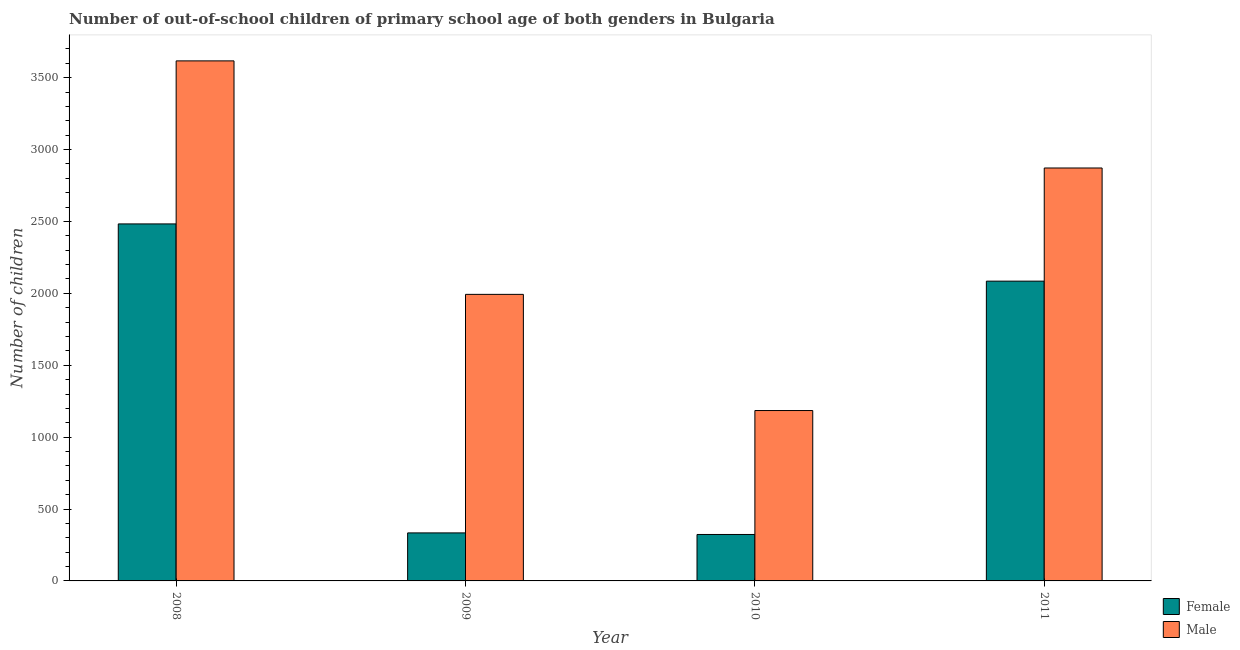How many groups of bars are there?
Make the answer very short. 4. How many bars are there on the 1st tick from the right?
Keep it short and to the point. 2. In how many cases, is the number of bars for a given year not equal to the number of legend labels?
Make the answer very short. 0. What is the number of female out-of-school students in 2010?
Provide a succinct answer. 323. Across all years, what is the maximum number of female out-of-school students?
Provide a short and direct response. 2483. Across all years, what is the minimum number of male out-of-school students?
Keep it short and to the point. 1185. In which year was the number of male out-of-school students maximum?
Keep it short and to the point. 2008. What is the total number of female out-of-school students in the graph?
Give a very brief answer. 5225. What is the difference between the number of male out-of-school students in 2009 and that in 2011?
Offer a terse response. -879. What is the difference between the number of male out-of-school students in 2011 and the number of female out-of-school students in 2008?
Your response must be concise. -745. What is the average number of male out-of-school students per year?
Your answer should be compact. 2416.75. In how many years, is the number of male out-of-school students greater than 300?
Your response must be concise. 4. What is the ratio of the number of female out-of-school students in 2008 to that in 2009?
Ensure brevity in your answer.  7.43. What is the difference between the highest and the second highest number of female out-of-school students?
Ensure brevity in your answer.  398. What is the difference between the highest and the lowest number of male out-of-school students?
Ensure brevity in your answer.  2432. Is the sum of the number of male out-of-school students in 2008 and 2009 greater than the maximum number of female out-of-school students across all years?
Your answer should be compact. Yes. How many bars are there?
Provide a short and direct response. 8. Does the graph contain any zero values?
Your answer should be compact. No. How many legend labels are there?
Offer a very short reply. 2. How are the legend labels stacked?
Offer a very short reply. Vertical. What is the title of the graph?
Make the answer very short. Number of out-of-school children of primary school age of both genders in Bulgaria. What is the label or title of the Y-axis?
Your answer should be very brief. Number of children. What is the Number of children in Female in 2008?
Your answer should be compact. 2483. What is the Number of children in Male in 2008?
Your response must be concise. 3617. What is the Number of children of Female in 2009?
Your response must be concise. 334. What is the Number of children of Male in 2009?
Offer a terse response. 1993. What is the Number of children in Female in 2010?
Provide a succinct answer. 323. What is the Number of children in Male in 2010?
Offer a terse response. 1185. What is the Number of children in Female in 2011?
Offer a terse response. 2085. What is the Number of children in Male in 2011?
Provide a short and direct response. 2872. Across all years, what is the maximum Number of children of Female?
Your response must be concise. 2483. Across all years, what is the maximum Number of children of Male?
Provide a succinct answer. 3617. Across all years, what is the minimum Number of children of Female?
Provide a succinct answer. 323. Across all years, what is the minimum Number of children in Male?
Offer a very short reply. 1185. What is the total Number of children of Female in the graph?
Offer a terse response. 5225. What is the total Number of children in Male in the graph?
Your response must be concise. 9667. What is the difference between the Number of children of Female in 2008 and that in 2009?
Offer a very short reply. 2149. What is the difference between the Number of children of Male in 2008 and that in 2009?
Ensure brevity in your answer.  1624. What is the difference between the Number of children of Female in 2008 and that in 2010?
Offer a very short reply. 2160. What is the difference between the Number of children of Male in 2008 and that in 2010?
Make the answer very short. 2432. What is the difference between the Number of children of Female in 2008 and that in 2011?
Offer a terse response. 398. What is the difference between the Number of children of Male in 2008 and that in 2011?
Provide a short and direct response. 745. What is the difference between the Number of children in Female in 2009 and that in 2010?
Your answer should be compact. 11. What is the difference between the Number of children in Male in 2009 and that in 2010?
Offer a terse response. 808. What is the difference between the Number of children of Female in 2009 and that in 2011?
Keep it short and to the point. -1751. What is the difference between the Number of children in Male in 2009 and that in 2011?
Make the answer very short. -879. What is the difference between the Number of children in Female in 2010 and that in 2011?
Offer a terse response. -1762. What is the difference between the Number of children of Male in 2010 and that in 2011?
Your response must be concise. -1687. What is the difference between the Number of children of Female in 2008 and the Number of children of Male in 2009?
Keep it short and to the point. 490. What is the difference between the Number of children in Female in 2008 and the Number of children in Male in 2010?
Keep it short and to the point. 1298. What is the difference between the Number of children of Female in 2008 and the Number of children of Male in 2011?
Make the answer very short. -389. What is the difference between the Number of children of Female in 2009 and the Number of children of Male in 2010?
Give a very brief answer. -851. What is the difference between the Number of children in Female in 2009 and the Number of children in Male in 2011?
Offer a very short reply. -2538. What is the difference between the Number of children of Female in 2010 and the Number of children of Male in 2011?
Your response must be concise. -2549. What is the average Number of children of Female per year?
Offer a very short reply. 1306.25. What is the average Number of children of Male per year?
Provide a succinct answer. 2416.75. In the year 2008, what is the difference between the Number of children in Female and Number of children in Male?
Offer a very short reply. -1134. In the year 2009, what is the difference between the Number of children of Female and Number of children of Male?
Offer a terse response. -1659. In the year 2010, what is the difference between the Number of children in Female and Number of children in Male?
Provide a succinct answer. -862. In the year 2011, what is the difference between the Number of children in Female and Number of children in Male?
Your answer should be compact. -787. What is the ratio of the Number of children of Female in 2008 to that in 2009?
Offer a terse response. 7.43. What is the ratio of the Number of children of Male in 2008 to that in 2009?
Your response must be concise. 1.81. What is the ratio of the Number of children in Female in 2008 to that in 2010?
Your answer should be compact. 7.69. What is the ratio of the Number of children in Male in 2008 to that in 2010?
Keep it short and to the point. 3.05. What is the ratio of the Number of children in Female in 2008 to that in 2011?
Offer a very short reply. 1.19. What is the ratio of the Number of children of Male in 2008 to that in 2011?
Give a very brief answer. 1.26. What is the ratio of the Number of children of Female in 2009 to that in 2010?
Your response must be concise. 1.03. What is the ratio of the Number of children in Male in 2009 to that in 2010?
Ensure brevity in your answer.  1.68. What is the ratio of the Number of children in Female in 2009 to that in 2011?
Give a very brief answer. 0.16. What is the ratio of the Number of children in Male in 2009 to that in 2011?
Your response must be concise. 0.69. What is the ratio of the Number of children of Female in 2010 to that in 2011?
Offer a terse response. 0.15. What is the ratio of the Number of children of Male in 2010 to that in 2011?
Your answer should be compact. 0.41. What is the difference between the highest and the second highest Number of children of Female?
Offer a terse response. 398. What is the difference between the highest and the second highest Number of children in Male?
Provide a short and direct response. 745. What is the difference between the highest and the lowest Number of children of Female?
Provide a succinct answer. 2160. What is the difference between the highest and the lowest Number of children in Male?
Provide a short and direct response. 2432. 